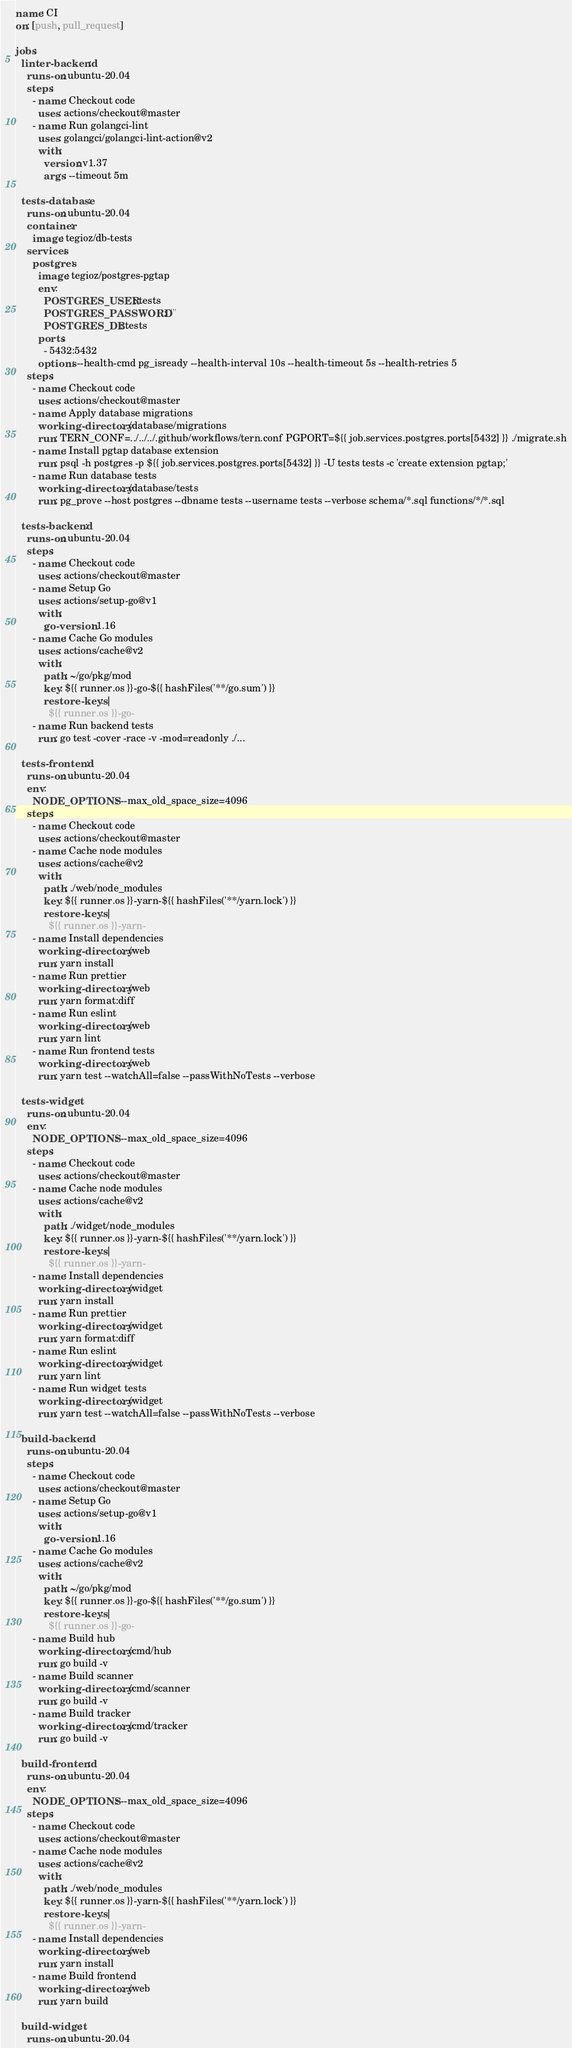<code> <loc_0><loc_0><loc_500><loc_500><_YAML_>name: CI
on: [push, pull_request]

jobs:
  linter-backend:
    runs-on: ubuntu-20.04
    steps:
      - name: Checkout code
        uses: actions/checkout@master
      - name: Run golangci-lint
        uses: golangci/golangci-lint-action@v2
        with:
          version: v1.37
          args: --timeout 5m

  tests-database:
    runs-on: ubuntu-20.04
    container:
      image: tegioz/db-tests
    services:
      postgres:
        image: tegioz/postgres-pgtap
        env:
          POSTGRES_USER: tests
          POSTGRES_PASSWORD: ""
          POSTGRES_DB: tests
        ports:
          - 5432:5432
        options: --health-cmd pg_isready --health-interval 10s --health-timeout 5s --health-retries 5
    steps:
      - name: Checkout code
        uses: actions/checkout@master
      - name: Apply database migrations
        working-directory: ./database/migrations
        run: TERN_CONF=../../../.github/workflows/tern.conf PGPORT=${{ job.services.postgres.ports[5432] }} ./migrate.sh
      - name: Install pgtap database extension
        run: psql -h postgres -p ${{ job.services.postgres.ports[5432] }} -U tests tests -c 'create extension pgtap;'
      - name: Run database tests
        working-directory: ./database/tests
        run: pg_prove --host postgres --dbname tests --username tests --verbose schema/*.sql functions/*/*.sql

  tests-backend:
    runs-on: ubuntu-20.04
    steps:
      - name: Checkout code
        uses: actions/checkout@master
      - name: Setup Go
        uses: actions/setup-go@v1
        with:
          go-version: 1.16
      - name: Cache Go modules
        uses: actions/cache@v2
        with:
          path: ~/go/pkg/mod
          key: ${{ runner.os }}-go-${{ hashFiles('**/go.sum') }}
          restore-keys: |
            ${{ runner.os }}-go-
      - name: Run backend tests
        run: go test -cover -race -v -mod=readonly ./...

  tests-frontend:
    runs-on: ubuntu-20.04
    env:
      NODE_OPTIONS: --max_old_space_size=4096
    steps:
      - name: Checkout code
        uses: actions/checkout@master
      - name: Cache node modules
        uses: actions/cache@v2
        with:
          path: ./web/node_modules
          key: ${{ runner.os }}-yarn-${{ hashFiles('**/yarn.lock') }}
          restore-keys: |
            ${{ runner.os }}-yarn-
      - name: Install dependencies
        working-directory: ./web
        run: yarn install
      - name: Run prettier
        working-directory: ./web
        run: yarn format:diff
      - name: Run eslint
        working-directory: ./web
        run: yarn lint
      - name: Run frontend tests
        working-directory: ./web
        run: yarn test --watchAll=false --passWithNoTests --verbose

  tests-widget:
    runs-on: ubuntu-20.04
    env:
      NODE_OPTIONS: --max_old_space_size=4096
    steps:
      - name: Checkout code
        uses: actions/checkout@master
      - name: Cache node modules
        uses: actions/cache@v2
        with:
          path: ./widget/node_modules
          key: ${{ runner.os }}-yarn-${{ hashFiles('**/yarn.lock') }}
          restore-keys: |
            ${{ runner.os }}-yarn-
      - name: Install dependencies
        working-directory: ./widget
        run: yarn install
      - name: Run prettier
        working-directory: ./widget
        run: yarn format:diff
      - name: Run eslint
        working-directory: ./widget
        run: yarn lint
      - name: Run widget tests
        working-directory: ./widget
        run: yarn test --watchAll=false --passWithNoTests --verbose

  build-backend:
    runs-on: ubuntu-20.04
    steps:
      - name: Checkout code
        uses: actions/checkout@master
      - name: Setup Go
        uses: actions/setup-go@v1
        with:
          go-version: 1.16
      - name: Cache Go modules
        uses: actions/cache@v2
        with:
          path: ~/go/pkg/mod
          key: ${{ runner.os }}-go-${{ hashFiles('**/go.sum') }}
          restore-keys: |
            ${{ runner.os }}-go-
      - name: Build hub
        working-directory: ./cmd/hub
        run: go build -v
      - name: Build scanner
        working-directory: ./cmd/scanner
        run: go build -v
      - name: Build tracker
        working-directory: ./cmd/tracker
        run: go build -v

  build-frontend:
    runs-on: ubuntu-20.04
    env:
      NODE_OPTIONS: --max_old_space_size=4096
    steps:
      - name: Checkout code
        uses: actions/checkout@master
      - name: Cache node modules
        uses: actions/cache@v2
        with:
          path: ./web/node_modules
          key: ${{ runner.os }}-yarn-${{ hashFiles('**/yarn.lock') }}
          restore-keys: |
            ${{ runner.os }}-yarn-
      - name: Install dependencies
        working-directory: ./web
        run: yarn install
      - name: Build frontend
        working-directory: ./web
        run: yarn build

  build-widget:
    runs-on: ubuntu-20.04</code> 